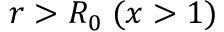Convert formula to latex. <formula><loc_0><loc_0><loc_500><loc_500>r > R _ { 0 } \, ( x > 1 )</formula> 